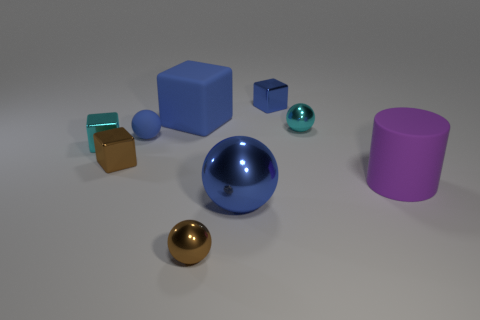What number of large gray cylinders are there?
Offer a very short reply. 0. The small cyan object that is in front of the tiny metallic sphere behind the brown object right of the small rubber sphere is made of what material?
Your answer should be very brief. Metal. Are there any purple things that have the same material as the large purple cylinder?
Offer a terse response. No. Do the big purple cylinder and the tiny blue sphere have the same material?
Your answer should be compact. Yes. How many blocks are small blue rubber objects or metal things?
Provide a succinct answer. 3. What color is the big thing that is made of the same material as the cyan cube?
Your answer should be compact. Blue. Are there fewer small cyan objects than blue objects?
Keep it short and to the point. Yes. There is a tiny cyan thing that is behind the tiny blue ball; does it have the same shape as the shiny thing on the left side of the tiny brown cube?
Your answer should be compact. No. What number of objects are small blue matte balls or purple things?
Give a very brief answer. 2. What color is the rubber thing that is the same size as the cyan metallic block?
Offer a very short reply. Blue. 